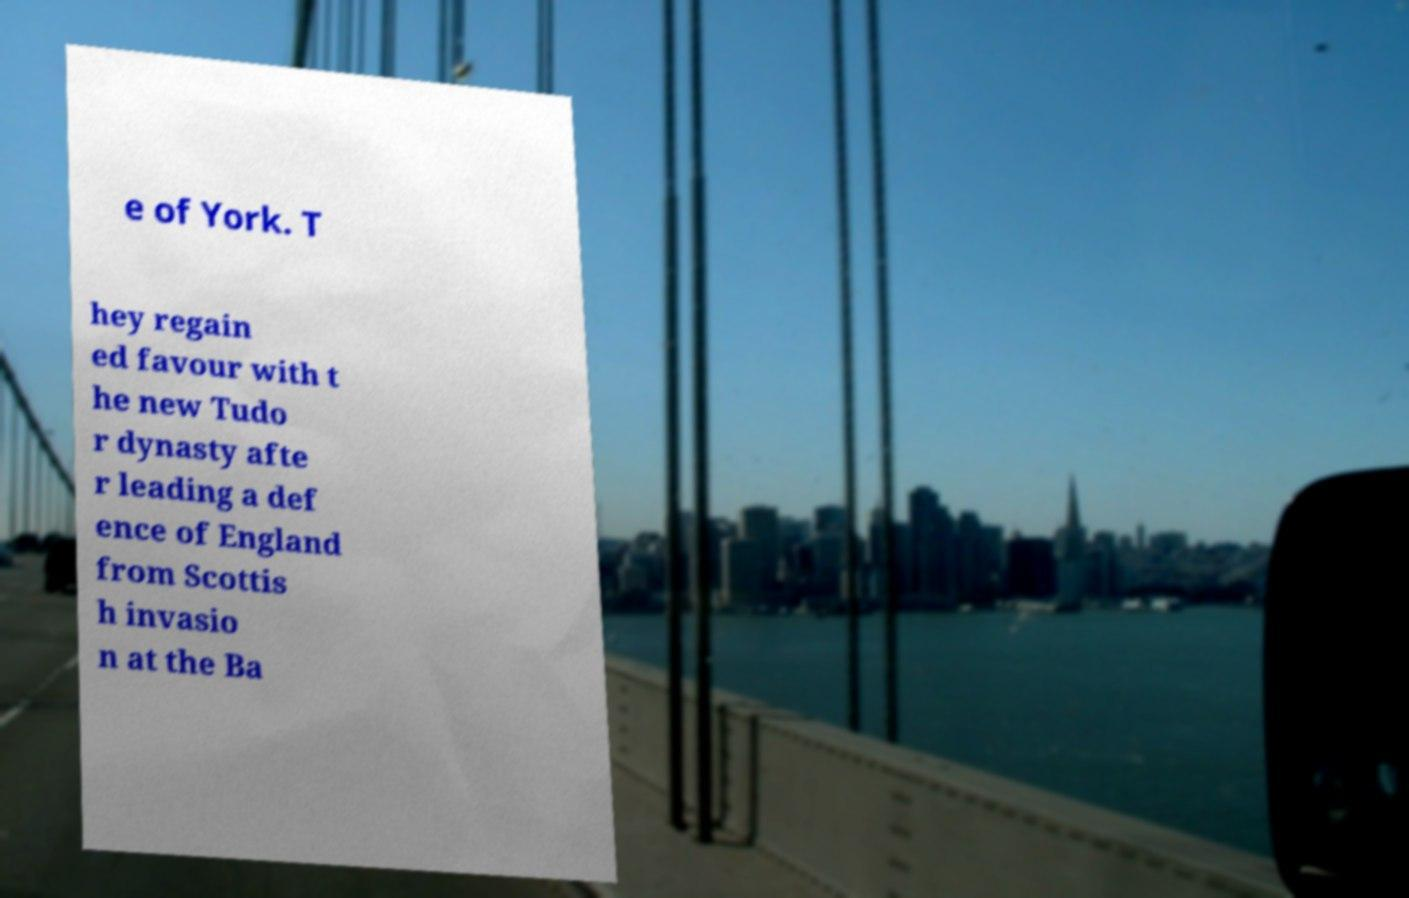There's text embedded in this image that I need extracted. Can you transcribe it verbatim? e of York. T hey regain ed favour with t he new Tudo r dynasty afte r leading a def ence of England from Scottis h invasio n at the Ba 